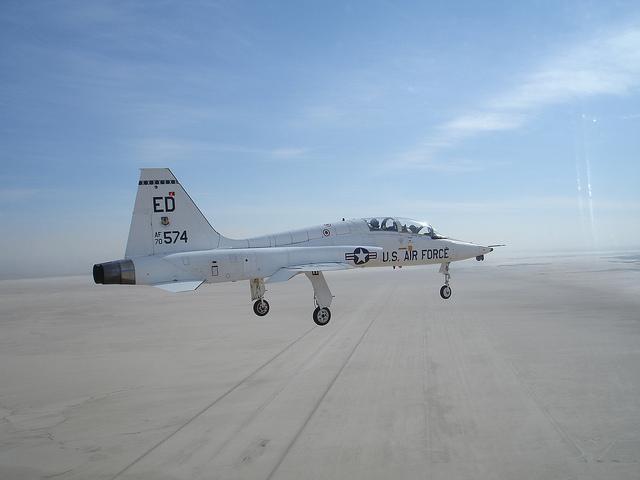How many people are on the plane?
Give a very brief answer. 2. How many planes can be seen?
Give a very brief answer. 1. How many planes are there?
Give a very brief answer. 1. How many wheels are visible?
Give a very brief answer. 3. How many people can fit in this plane?
Give a very brief answer. 2. 